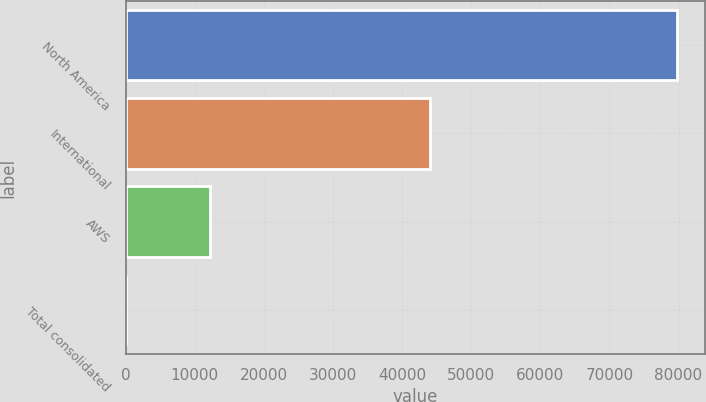Convert chart to OTSL. <chart><loc_0><loc_0><loc_500><loc_500><bar_chart><fcel>North America<fcel>International<fcel>AWS<fcel>Total consolidated<nl><fcel>79785<fcel>43983<fcel>12219<fcel>27<nl></chart> 